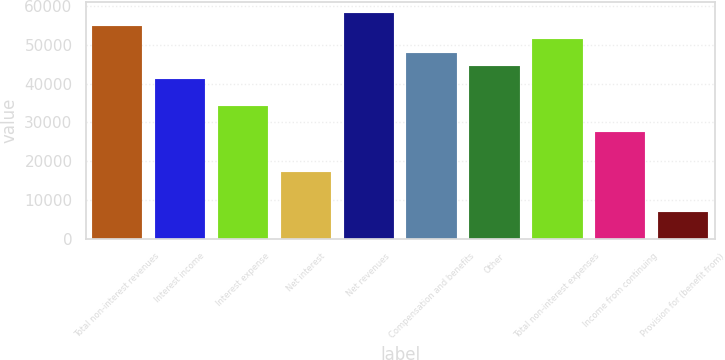Convert chart to OTSL. <chart><loc_0><loc_0><loc_500><loc_500><bar_chart><fcel>Total non-interest revenues<fcel>Interest income<fcel>Interest expense<fcel>Net interest<fcel>Net revenues<fcel>Compensation and benefits<fcel>Other<fcel>Total non-interest expenses<fcel>Income from continuing<fcel>Provision for (benefit from)<nl><fcel>54831.6<fcel>41127.2<fcel>34275<fcel>17144.5<fcel>58257.7<fcel>47979.4<fcel>44553.3<fcel>51405.5<fcel>27422.8<fcel>6866.2<nl></chart> 